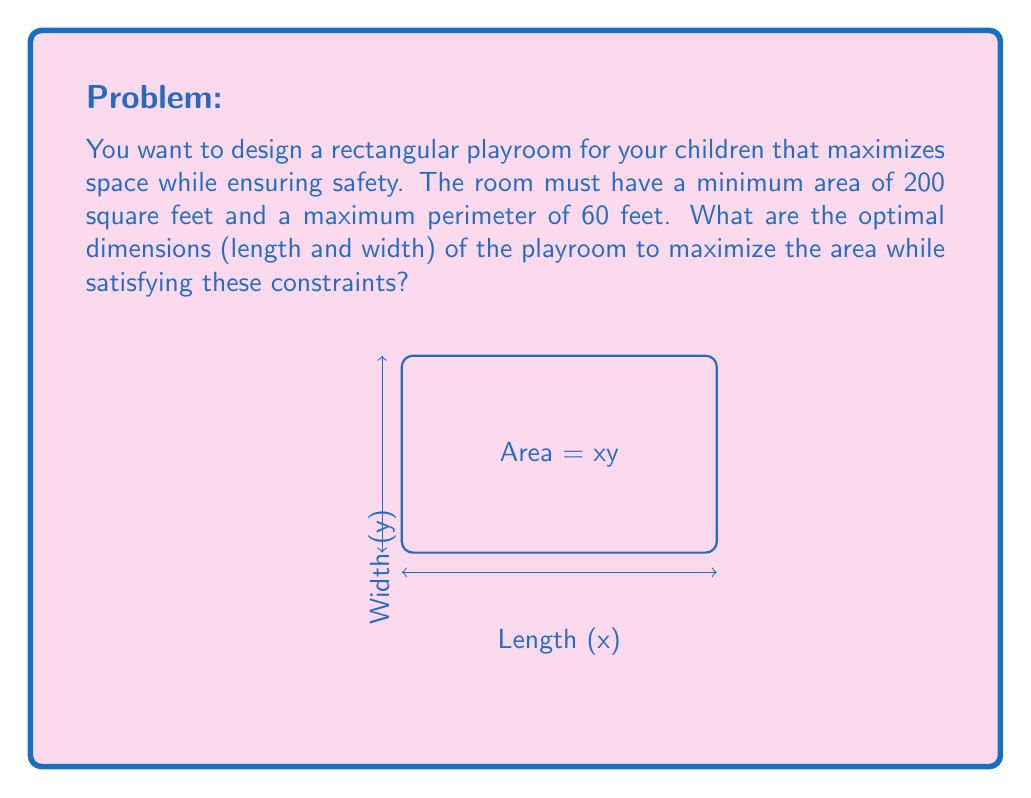Can you answer this question? Let's approach this step-by-step:

1) Let x be the length and y be the width of the room.

2) We need to maximize the area: A = xy

3) Constraints:
   a) Area ≥ 200 sq ft: xy ≥ 200
   b) Perimeter ≤ 60 ft: 2x + 2y ≤ 60

4) From the perimeter constraint:
   2x + 2y ≤ 60
   x + y ≤ 30

5) We can express y in terms of x:
   y ≤ 30 - x

6) Now, we can rewrite our area function:
   A = x(30-x) = 30x - x²

7) To find the maximum, we differentiate A with respect to x and set it to zero:
   $$\frac{dA}{dx} = 30 - 2x = 0$$
   $$30 = 2x$$
   $$x = 15$$

8) This gives us the optimal length. The optimal width will be:
   y = 30 - 15 = 15

9) Let's verify the constraints:
   Area: 15 * 15 = 225 sq ft (≥ 200 sq ft)
   Perimeter: 2(15) + 2(15) = 60 ft (≤ 60 ft)

Therefore, the optimal dimensions are 15 feet by 15 feet, creating a square playroom.
Answer: 15 ft × 15 ft 